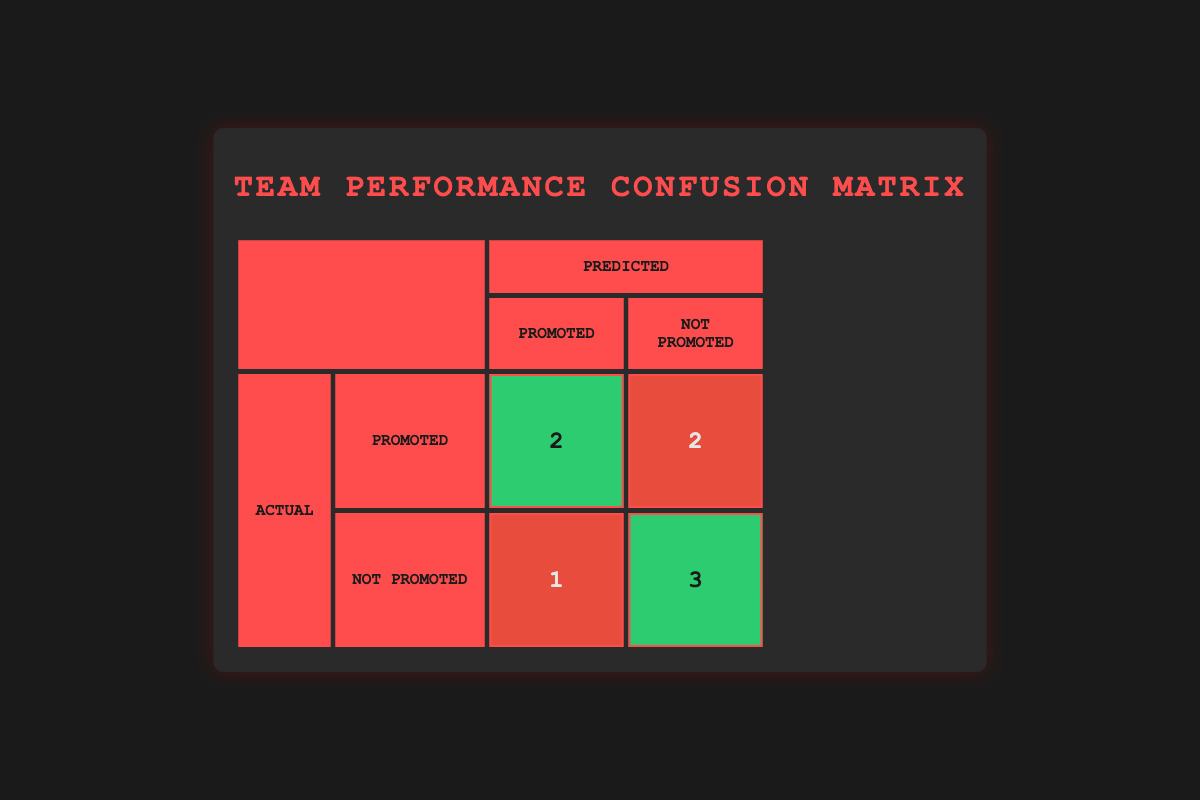What are the total number of team members evaluated? There are a total of eight team members evaluated as shown by the list in the table.
Answer: 8 How many team members were correctly identified as Promoted? According to the table, the value in the True Positive cell indicates that two team members were correctly identified as Promoted.
Answer: 2 What is the number of team members who were incorrectly predicted as Promoted? The table shows the number of False Positives (1) for team members who were not actually promoted but predicted to be.
Answer: 1 What is the total number of team members actually Not Promoted? By summing the Not Promoted column in the Actual row, we find that there are four members actually Not Promoted.
Answer: 4 How many team members were predicted as Not Promoted? Looking at the predicted columns, adding those predicted as Not Promoted gives us 4 (Bob Smith, George Hill, and the two in Not Promoted actual).
Answer: 4 Are the number of True Negatives greater than False Positives? From the table, True Negatives (3) are compared with False Positives (1), so yes, True Negatives are greater than False Positives.
Answer: Yes What is the total number of False Negatives? The table indicates that there is 1 False Negative, which refers to a team member who was Promoted but not predicted as such.
Answer: 1 Which type of prediction was made for George Hill? George Hill is listed as Not Promoted in the predicted column, despite his actual status being Promoted.
Answer: Not Promoted How many total incorrect predictions were made? The total number of incorrect predictions is the sum of False Positives (1) and False Negatives (2), resulting in a total of 3 incorrect predictions.
Answer: 3 